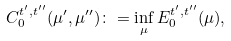Convert formula to latex. <formula><loc_0><loc_0><loc_500><loc_500>C _ { 0 } ^ { t ^ { \prime } , t ^ { \prime \prime } } ( \mu ^ { \prime } , \mu ^ { \prime \prime } ) \colon = \inf _ { \mu } E _ { 0 } ^ { t ^ { \prime } , t ^ { \prime \prime } } ( \mu ) ,</formula> 